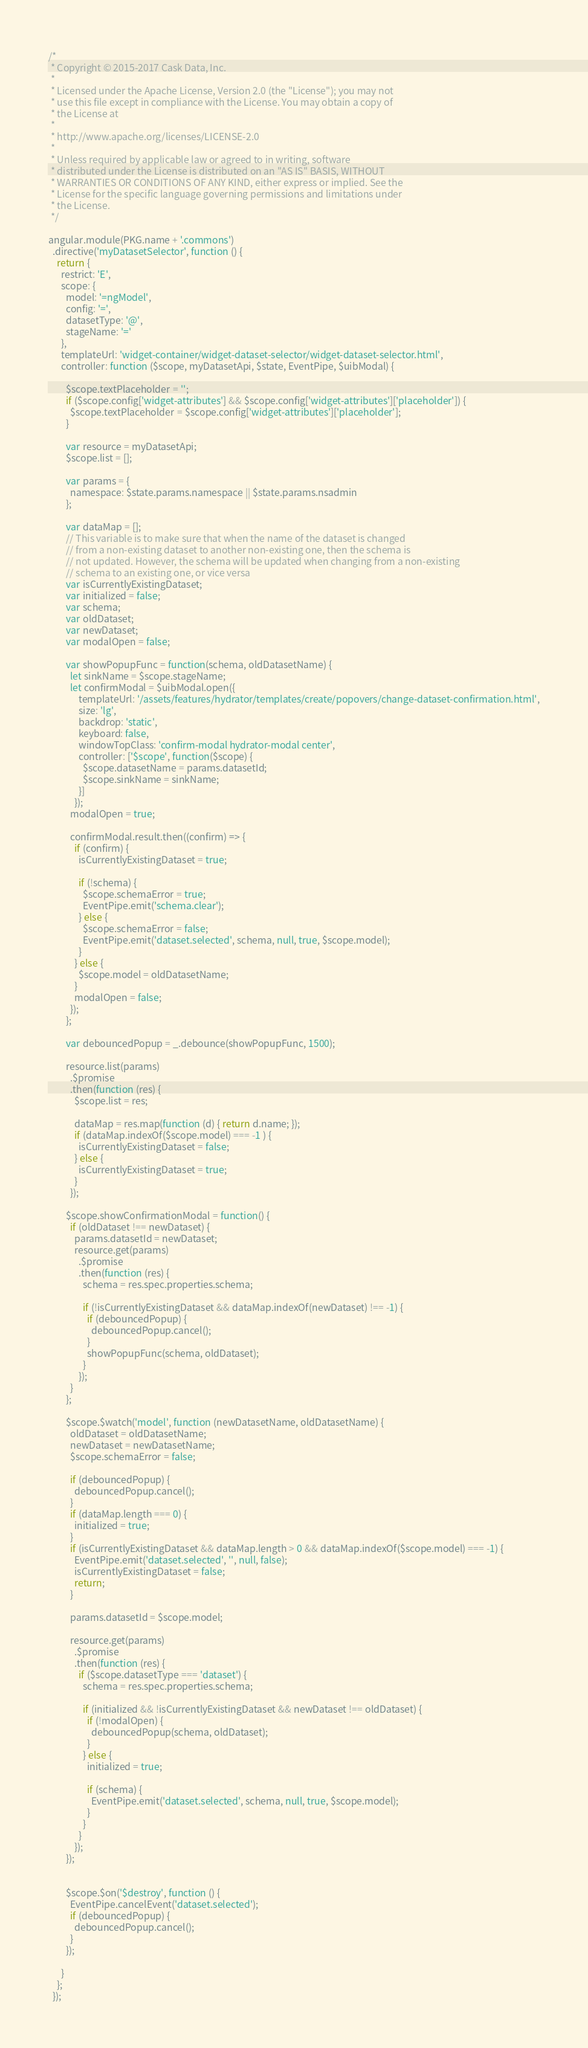<code> <loc_0><loc_0><loc_500><loc_500><_JavaScript_>/*
 * Copyright © 2015-2017 Cask Data, Inc.
 *
 * Licensed under the Apache License, Version 2.0 (the "License"); you may not
 * use this file except in compliance with the License. You may obtain a copy of
 * the License at
 *
 * http://www.apache.org/licenses/LICENSE-2.0
 *
 * Unless required by applicable law or agreed to in writing, software
 * distributed under the License is distributed on an "AS IS" BASIS, WITHOUT
 * WARRANTIES OR CONDITIONS OF ANY KIND, either express or implied. See the
 * License for the specific language governing permissions and limitations under
 * the License.
 */

angular.module(PKG.name + '.commons')
  .directive('myDatasetSelector', function () {
    return {
      restrict: 'E',
      scope: {
        model: '=ngModel',
        config: '=',
        datasetType: '@',
        stageName: '='
      },
      templateUrl: 'widget-container/widget-dataset-selector/widget-dataset-selector.html',
      controller: function ($scope, myDatasetApi, $state, EventPipe, $uibModal) {

        $scope.textPlaceholder = '';
        if ($scope.config['widget-attributes'] && $scope.config['widget-attributes']['placeholder']) {
          $scope.textPlaceholder = $scope.config['widget-attributes']['placeholder'];
        }

        var resource = myDatasetApi;
        $scope.list = [];

        var params = {
          namespace: $state.params.namespace || $state.params.nsadmin
        };

        var dataMap = [];
        // This variable is to make sure that when the name of the dataset is changed
        // from a non-existing dataset to another non-existing one, then the schema is
        // not updated. However, the schema will be updated when changing from a non-existing
        // schema to an existing one, or vice versa
        var isCurrentlyExistingDataset;
        var initialized = false;
        var schema;
        var oldDataset;
        var newDataset;
        var modalOpen = false;

        var showPopupFunc = function(schema, oldDatasetName) {
          let sinkName = $scope.stageName;
          let confirmModal = $uibModal.open({
              templateUrl: '/assets/features/hydrator/templates/create/popovers/change-dataset-confirmation.html',
              size: 'lg',
              backdrop: 'static',
              keyboard: false,
              windowTopClass: 'confirm-modal hydrator-modal center',
              controller: ['$scope', function($scope) {
                $scope.datasetName = params.datasetId;
                $scope.sinkName = sinkName;
              }]
            });
          modalOpen = true;

          confirmModal.result.then((confirm) => {
            if (confirm) {
              isCurrentlyExistingDataset = true;

              if (!schema) {
                $scope.schemaError = true;
                EventPipe.emit('schema.clear');
              } else {
                $scope.schemaError = false;
                EventPipe.emit('dataset.selected', schema, null, true, $scope.model);
              }
            } else {
              $scope.model = oldDatasetName;
            }
            modalOpen = false;
          });
        };

        var debouncedPopup = _.debounce(showPopupFunc, 1500);

        resource.list(params)
          .$promise
          .then(function (res) {
            $scope.list = res;

            dataMap = res.map(function (d) { return d.name; });
            if (dataMap.indexOf($scope.model) === -1 ) {
              isCurrentlyExistingDataset = false;
            } else {
              isCurrentlyExistingDataset = true;
            }
          });

        $scope.showConfirmationModal = function() {
          if (oldDataset !== newDataset) {
            params.datasetId = newDataset;
            resource.get(params)
              .$promise
              .then(function (res) {
                schema = res.spec.properties.schema;

                if (!isCurrentlyExistingDataset && dataMap.indexOf(newDataset) !== -1) {
                  if (debouncedPopup) {
                    debouncedPopup.cancel();
                  }
                  showPopupFunc(schema, oldDataset);
                }
              });
          }
        };

        $scope.$watch('model', function (newDatasetName, oldDatasetName) {
          oldDataset = oldDatasetName;
          newDataset = newDatasetName;
          $scope.schemaError = false;

          if (debouncedPopup) {
            debouncedPopup.cancel();
          }
          if (dataMap.length === 0) {
            initialized = true;
          }
          if (isCurrentlyExistingDataset && dataMap.length > 0 && dataMap.indexOf($scope.model) === -1) {
            EventPipe.emit('dataset.selected', '', null, false);
            isCurrentlyExistingDataset = false;
            return;
          }

          params.datasetId = $scope.model;

          resource.get(params)
            .$promise
            .then(function (res) {
              if ($scope.datasetType === 'dataset') {
                schema = res.spec.properties.schema;

                if (initialized && !isCurrentlyExistingDataset && newDataset !== oldDataset) {
                  if (!modalOpen) {
                    debouncedPopup(schema, oldDataset);
                  }
                } else {
                  initialized = true;

                  if (schema) {
                    EventPipe.emit('dataset.selected', schema, null, true, $scope.model);
                  }
                }
              }
            });
        });


        $scope.$on('$destroy', function () {
          EventPipe.cancelEvent('dataset.selected');
          if (debouncedPopup) {
            debouncedPopup.cancel();
          }
        });

      }
    };
  });
</code> 